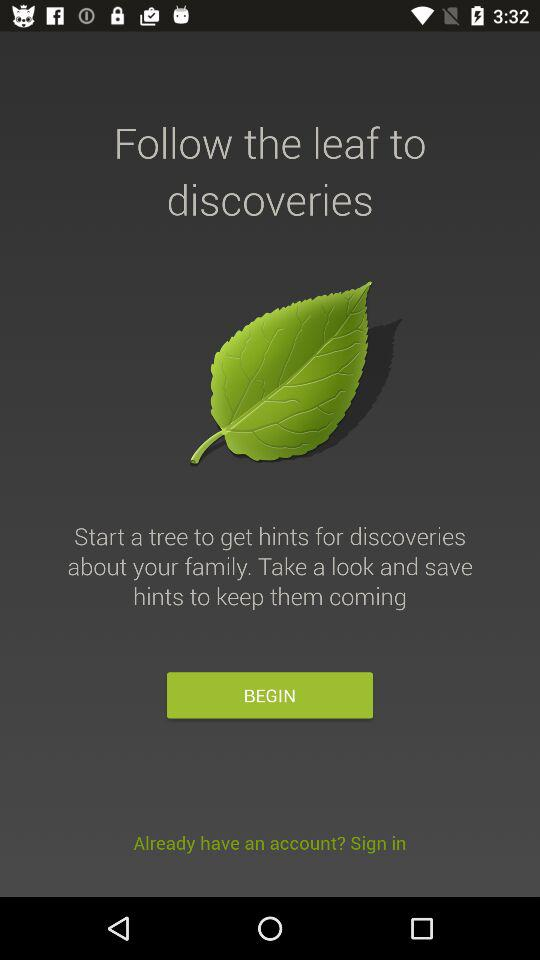What is the name of application?
When the provided information is insufficient, respond with <no answer>. <no answer> 